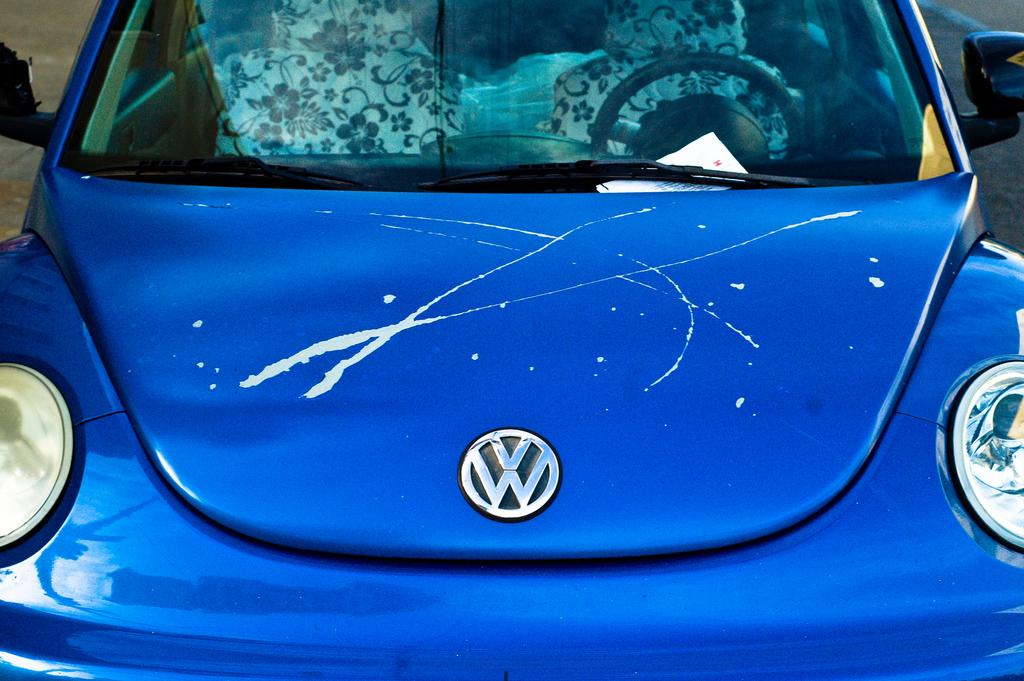What is the main subject of the image? The main subject of the image is a car. Where is the car located in the image? The car is on the road in the image. What is placed on the car? There is a paper on the car. What can be seen inside the car through the glass? The car's interior is visible through the glass, including a steering wheel and seats. What type of fear can be seen on the driver's face in the image? There is no driver's face visible in the image, and therefore no fear can be observed. How many fingers are visible on the driver's hand in the image? There is no driver's hand visible in the image, and therefore no fingers can be counted. 